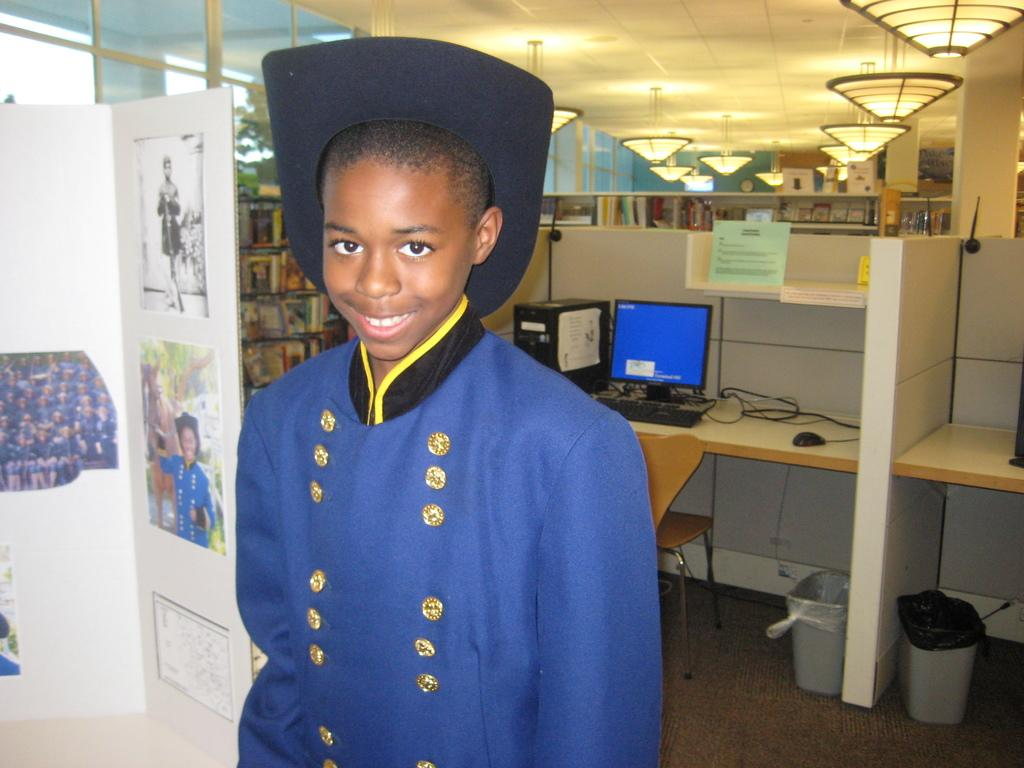Who is present in the image? There is a man in the image. What is the man's facial expression? The man is smiling. What can be seen on the table in the image? There is a computer on a table in the image. What type of furniture is in the image? There is a chair in the image. What is used for storing books in the image? There is a bookshelf in the image. What is on the wall in the image? There are posters on the wall in the image. What type of pen is the man using to write on the form in the image? There is no form or pen present in the image; the man is simply smiling. 